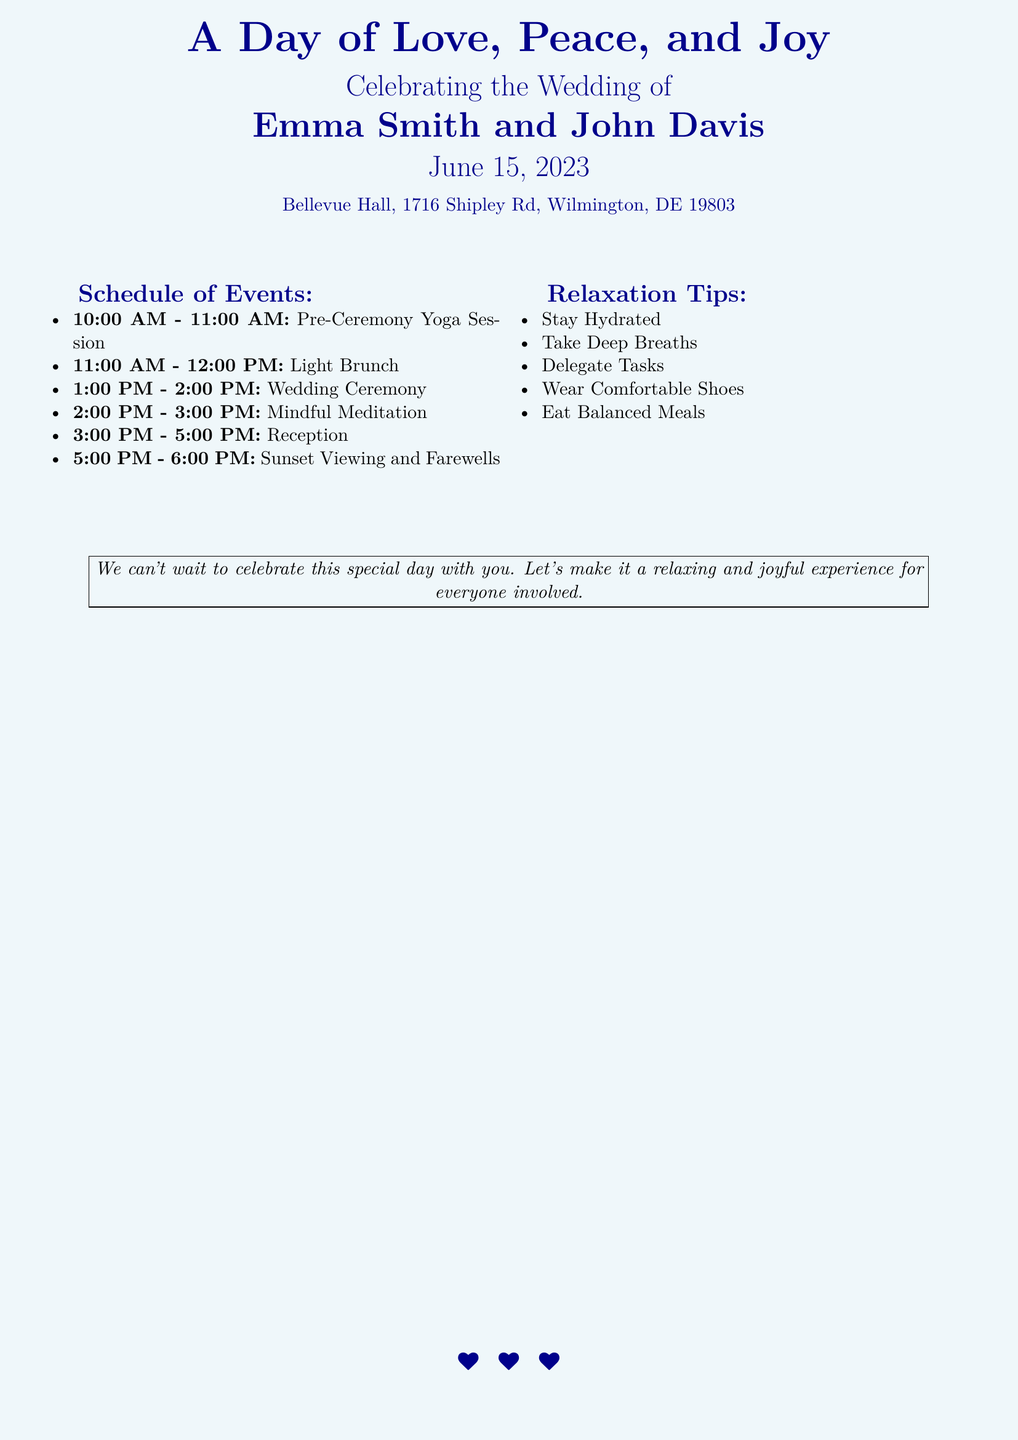what is the name of the bride? The bride's name is provided in the document as part of the title.
Answer: Emma Smith what is the date of the wedding? The date is explicitly mentioned in the document summary.
Answer: June 15, 2023 where is the wedding taking place? The location is clearly outlined in the address section of the document.
Answer: Bellevue Hall, 1716 Shipley Rd, Wilmington, DE 19803 what time does the wedding ceremony start? The start time for the ceremony is listed under the schedule of events.
Answer: 1:00 PM how long is the reception? The duration of the reception is specified in the schedule of events.
Answer: 2 hours what relaxation tip advises staying comfortable? This tip refers to maintaining comfort throughout the day, highlighted in the relaxation tips section.
Answer: Wear Comfortable Shoes how many events are listed in the schedule? The total number of events can be counted directly from the schedule section of the document.
Answer: 6 events what is the purpose of the pre-ceremony yoga session? The session is indicated to set the tone for the day, providing a rationale behind its inclusion in the schedule.
Answer: Stress relief what should attendees do during the sunset viewing? The activity during sunset viewing is mentioned as part of the farewell events.
Answer: Farewells 